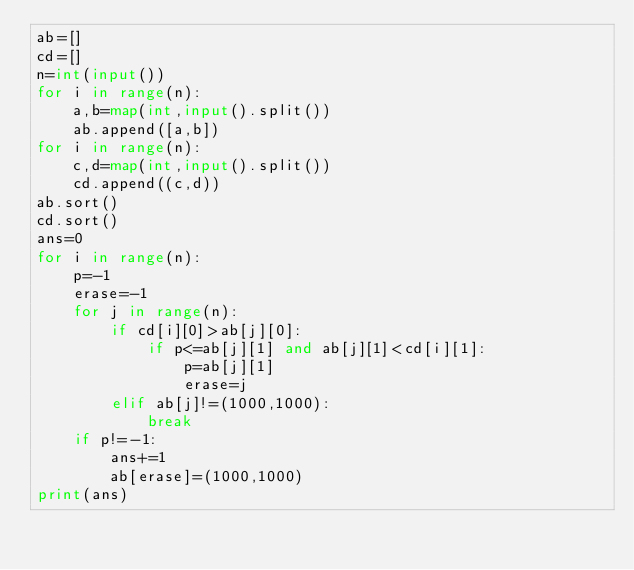<code> <loc_0><loc_0><loc_500><loc_500><_Python_>ab=[]
cd=[]
n=int(input())
for i in range(n):
	a,b=map(int,input().split())
	ab.append([a,b])
for i in range(n):
	c,d=map(int,input().split())
	cd.append((c,d))
ab.sort()
cd.sort()
ans=0
for i in range(n):
	p=-1
	erase=-1
	for j in range(n):
		if cd[i][0]>ab[j][0]:
			if p<=ab[j][1] and ab[j][1]<cd[i][1]:
				p=ab[j][1]
				erase=j
		elif ab[j]!=(1000,1000):
			break
	if p!=-1:
		ans+=1
		ab[erase]=(1000,1000)
print(ans)
</code> 